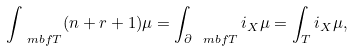Convert formula to latex. <formula><loc_0><loc_0><loc_500><loc_500>\int _ { \ m b f T } ( n + r + 1 ) \mu = \int _ { \partial \ m b f T } i _ { X } \mu = \int _ { T } i _ { X } \mu ,</formula> 